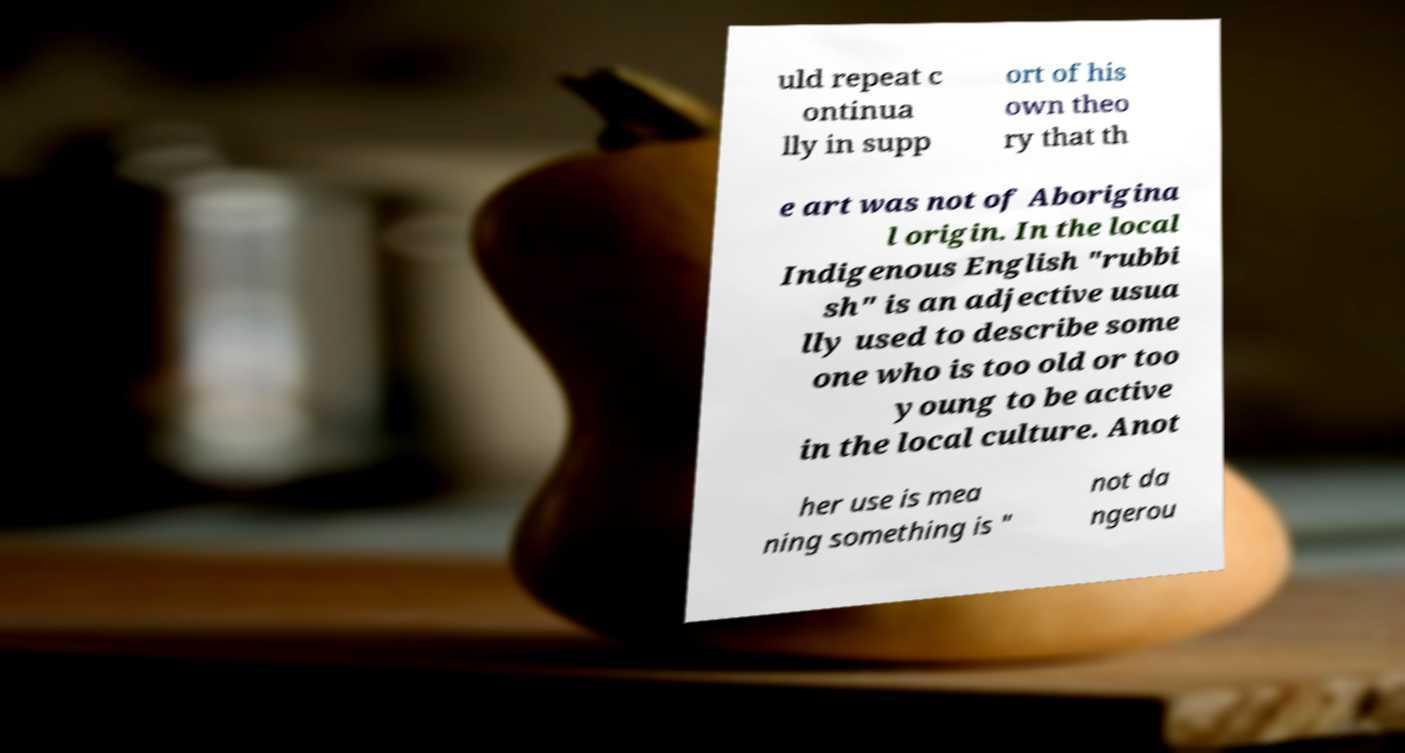For documentation purposes, I need the text within this image transcribed. Could you provide that? uld repeat c ontinua lly in supp ort of his own theo ry that th e art was not of Aborigina l origin. In the local Indigenous English "rubbi sh" is an adjective usua lly used to describe some one who is too old or too young to be active in the local culture. Anot her use is mea ning something is " not da ngerou 